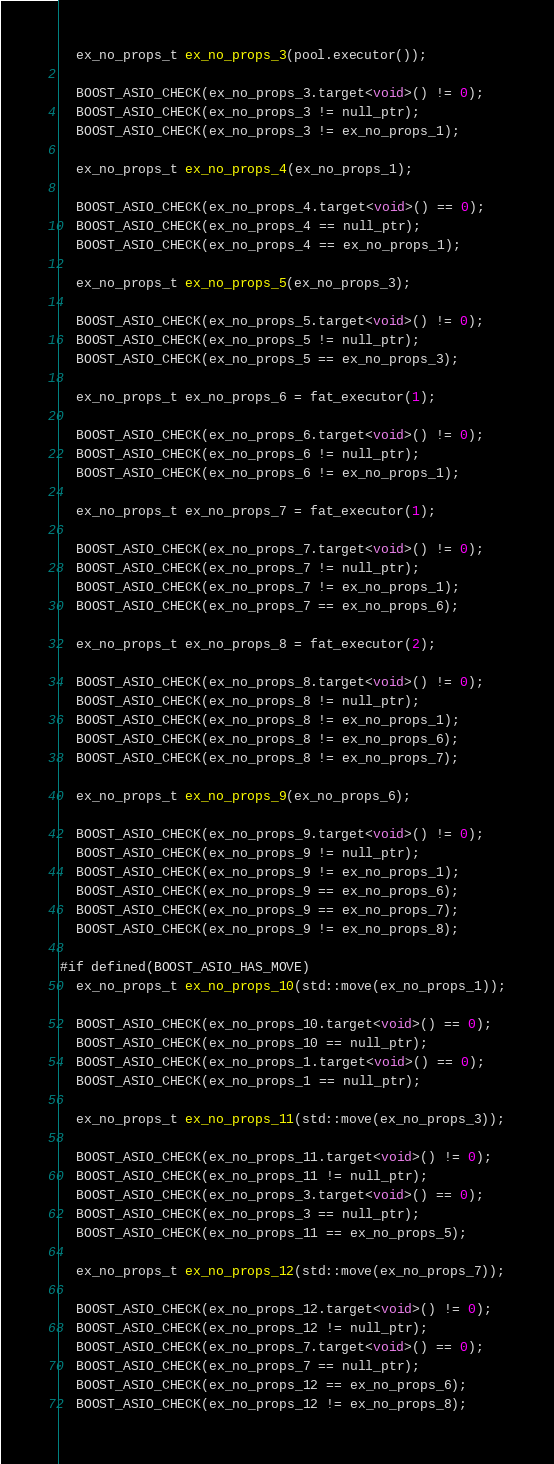Convert code to text. <code><loc_0><loc_0><loc_500><loc_500><_C++_>
  ex_no_props_t ex_no_props_3(pool.executor());

  BOOST_ASIO_CHECK(ex_no_props_3.target<void>() != 0);
  BOOST_ASIO_CHECK(ex_no_props_3 != null_ptr);
  BOOST_ASIO_CHECK(ex_no_props_3 != ex_no_props_1);

  ex_no_props_t ex_no_props_4(ex_no_props_1);

  BOOST_ASIO_CHECK(ex_no_props_4.target<void>() == 0);
  BOOST_ASIO_CHECK(ex_no_props_4 == null_ptr);
  BOOST_ASIO_CHECK(ex_no_props_4 == ex_no_props_1);

  ex_no_props_t ex_no_props_5(ex_no_props_3);

  BOOST_ASIO_CHECK(ex_no_props_5.target<void>() != 0);
  BOOST_ASIO_CHECK(ex_no_props_5 != null_ptr);
  BOOST_ASIO_CHECK(ex_no_props_5 == ex_no_props_3);

  ex_no_props_t ex_no_props_6 = fat_executor(1);

  BOOST_ASIO_CHECK(ex_no_props_6.target<void>() != 0);
  BOOST_ASIO_CHECK(ex_no_props_6 != null_ptr);
  BOOST_ASIO_CHECK(ex_no_props_6 != ex_no_props_1);

  ex_no_props_t ex_no_props_7 = fat_executor(1);

  BOOST_ASIO_CHECK(ex_no_props_7.target<void>() != 0);
  BOOST_ASIO_CHECK(ex_no_props_7 != null_ptr);
  BOOST_ASIO_CHECK(ex_no_props_7 != ex_no_props_1);
  BOOST_ASIO_CHECK(ex_no_props_7 == ex_no_props_6);

  ex_no_props_t ex_no_props_8 = fat_executor(2);

  BOOST_ASIO_CHECK(ex_no_props_8.target<void>() != 0);
  BOOST_ASIO_CHECK(ex_no_props_8 != null_ptr);
  BOOST_ASIO_CHECK(ex_no_props_8 != ex_no_props_1);
  BOOST_ASIO_CHECK(ex_no_props_8 != ex_no_props_6);
  BOOST_ASIO_CHECK(ex_no_props_8 != ex_no_props_7);

  ex_no_props_t ex_no_props_9(ex_no_props_6);

  BOOST_ASIO_CHECK(ex_no_props_9.target<void>() != 0);
  BOOST_ASIO_CHECK(ex_no_props_9 != null_ptr);
  BOOST_ASIO_CHECK(ex_no_props_9 != ex_no_props_1);
  BOOST_ASIO_CHECK(ex_no_props_9 == ex_no_props_6);
  BOOST_ASIO_CHECK(ex_no_props_9 == ex_no_props_7);
  BOOST_ASIO_CHECK(ex_no_props_9 != ex_no_props_8);

#if defined(BOOST_ASIO_HAS_MOVE)
  ex_no_props_t ex_no_props_10(std::move(ex_no_props_1));

  BOOST_ASIO_CHECK(ex_no_props_10.target<void>() == 0);
  BOOST_ASIO_CHECK(ex_no_props_10 == null_ptr);
  BOOST_ASIO_CHECK(ex_no_props_1.target<void>() == 0);
  BOOST_ASIO_CHECK(ex_no_props_1 == null_ptr);

  ex_no_props_t ex_no_props_11(std::move(ex_no_props_3));

  BOOST_ASIO_CHECK(ex_no_props_11.target<void>() != 0);
  BOOST_ASIO_CHECK(ex_no_props_11 != null_ptr);
  BOOST_ASIO_CHECK(ex_no_props_3.target<void>() == 0);
  BOOST_ASIO_CHECK(ex_no_props_3 == null_ptr);
  BOOST_ASIO_CHECK(ex_no_props_11 == ex_no_props_5);

  ex_no_props_t ex_no_props_12(std::move(ex_no_props_7));

  BOOST_ASIO_CHECK(ex_no_props_12.target<void>() != 0);
  BOOST_ASIO_CHECK(ex_no_props_12 != null_ptr);
  BOOST_ASIO_CHECK(ex_no_props_7.target<void>() == 0);
  BOOST_ASIO_CHECK(ex_no_props_7 == null_ptr);
  BOOST_ASIO_CHECK(ex_no_props_12 == ex_no_props_6);
  BOOST_ASIO_CHECK(ex_no_props_12 != ex_no_props_8);</code> 